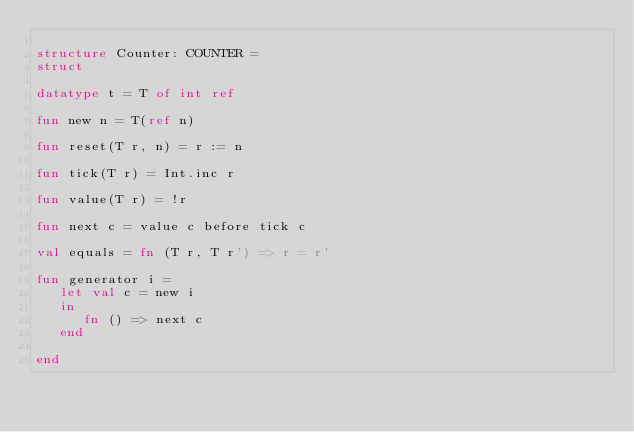<code> <loc_0><loc_0><loc_500><loc_500><_SML_>
structure Counter: COUNTER =
struct

datatype t = T of int ref

fun new n = T(ref n)

fun reset(T r, n) = r := n

fun tick(T r) = Int.inc r

fun value(T r) = !r

fun next c = value c before tick c

val equals = fn (T r, T r') => r = r'

fun generator i =
   let val c = new i
   in
      fn () => next c
   end

end
</code> 